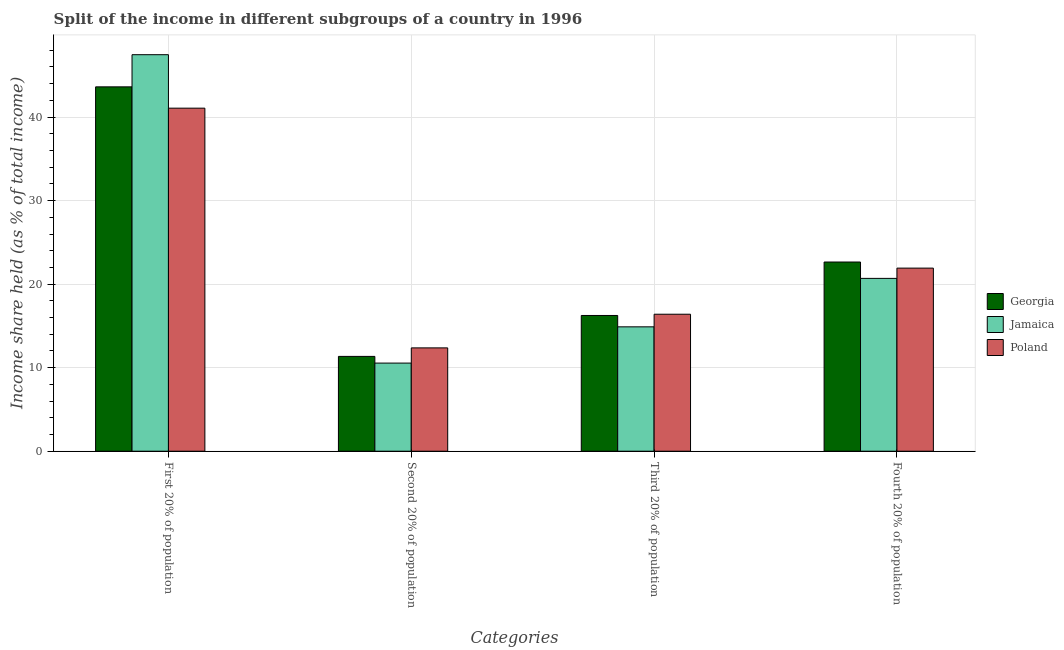How many groups of bars are there?
Offer a very short reply. 4. How many bars are there on the 1st tick from the left?
Provide a short and direct response. 3. How many bars are there on the 2nd tick from the right?
Ensure brevity in your answer.  3. What is the label of the 4th group of bars from the left?
Offer a terse response. Fourth 20% of population. What is the share of the income held by fourth 20% of the population in Georgia?
Give a very brief answer. 22.65. Across all countries, what is the maximum share of the income held by first 20% of the population?
Offer a terse response. 47.47. Across all countries, what is the minimum share of the income held by fourth 20% of the population?
Offer a terse response. 20.69. In which country was the share of the income held by third 20% of the population minimum?
Your response must be concise. Jamaica. What is the total share of the income held by fourth 20% of the population in the graph?
Provide a short and direct response. 65.26. What is the difference between the share of the income held by third 20% of the population in Poland and that in Georgia?
Your answer should be very brief. 0.15. What is the difference between the share of the income held by third 20% of the population in Jamaica and the share of the income held by first 20% of the population in Poland?
Your answer should be very brief. -26.18. What is the average share of the income held by third 20% of the population per country?
Provide a short and direct response. 15.85. What is the difference between the share of the income held by third 20% of the population and share of the income held by second 20% of the population in Georgia?
Keep it short and to the point. 4.9. What is the ratio of the share of the income held by first 20% of the population in Jamaica to that in Poland?
Give a very brief answer. 1.16. Is the difference between the share of the income held by fourth 20% of the population in Jamaica and Georgia greater than the difference between the share of the income held by first 20% of the population in Jamaica and Georgia?
Your answer should be compact. No. What is the difference between the highest and the second highest share of the income held by second 20% of the population?
Keep it short and to the point. 1.02. What is the difference between the highest and the lowest share of the income held by first 20% of the population?
Keep it short and to the point. 6.4. Is it the case that in every country, the sum of the share of the income held by first 20% of the population and share of the income held by third 20% of the population is greater than the sum of share of the income held by second 20% of the population and share of the income held by fourth 20% of the population?
Offer a very short reply. No. What does the 2nd bar from the left in Second 20% of population represents?
Keep it short and to the point. Jamaica. Is it the case that in every country, the sum of the share of the income held by first 20% of the population and share of the income held by second 20% of the population is greater than the share of the income held by third 20% of the population?
Ensure brevity in your answer.  Yes. Are all the bars in the graph horizontal?
Your answer should be very brief. No. Are the values on the major ticks of Y-axis written in scientific E-notation?
Give a very brief answer. No. Does the graph contain grids?
Provide a succinct answer. Yes. Where does the legend appear in the graph?
Provide a succinct answer. Center right. What is the title of the graph?
Provide a short and direct response. Split of the income in different subgroups of a country in 1996. What is the label or title of the X-axis?
Provide a succinct answer. Categories. What is the label or title of the Y-axis?
Keep it short and to the point. Income share held (as % of total income). What is the Income share held (as % of total income) in Georgia in First 20% of population?
Provide a short and direct response. 43.62. What is the Income share held (as % of total income) in Jamaica in First 20% of population?
Your answer should be very brief. 47.47. What is the Income share held (as % of total income) in Poland in First 20% of population?
Give a very brief answer. 41.07. What is the Income share held (as % of total income) in Georgia in Second 20% of population?
Provide a short and direct response. 11.35. What is the Income share held (as % of total income) in Jamaica in Second 20% of population?
Provide a succinct answer. 10.55. What is the Income share held (as % of total income) in Poland in Second 20% of population?
Ensure brevity in your answer.  12.37. What is the Income share held (as % of total income) of Georgia in Third 20% of population?
Provide a succinct answer. 16.25. What is the Income share held (as % of total income) in Jamaica in Third 20% of population?
Ensure brevity in your answer.  14.89. What is the Income share held (as % of total income) of Poland in Third 20% of population?
Your answer should be compact. 16.4. What is the Income share held (as % of total income) of Georgia in Fourth 20% of population?
Give a very brief answer. 22.65. What is the Income share held (as % of total income) of Jamaica in Fourth 20% of population?
Offer a terse response. 20.69. What is the Income share held (as % of total income) in Poland in Fourth 20% of population?
Offer a very short reply. 21.92. Across all Categories, what is the maximum Income share held (as % of total income) in Georgia?
Your answer should be very brief. 43.62. Across all Categories, what is the maximum Income share held (as % of total income) in Jamaica?
Keep it short and to the point. 47.47. Across all Categories, what is the maximum Income share held (as % of total income) in Poland?
Provide a short and direct response. 41.07. Across all Categories, what is the minimum Income share held (as % of total income) in Georgia?
Your response must be concise. 11.35. Across all Categories, what is the minimum Income share held (as % of total income) in Jamaica?
Give a very brief answer. 10.55. Across all Categories, what is the minimum Income share held (as % of total income) of Poland?
Keep it short and to the point. 12.37. What is the total Income share held (as % of total income) of Georgia in the graph?
Provide a short and direct response. 93.87. What is the total Income share held (as % of total income) in Jamaica in the graph?
Your response must be concise. 93.6. What is the total Income share held (as % of total income) of Poland in the graph?
Offer a terse response. 91.76. What is the difference between the Income share held (as % of total income) of Georgia in First 20% of population and that in Second 20% of population?
Give a very brief answer. 32.27. What is the difference between the Income share held (as % of total income) in Jamaica in First 20% of population and that in Second 20% of population?
Your answer should be compact. 36.92. What is the difference between the Income share held (as % of total income) in Poland in First 20% of population and that in Second 20% of population?
Offer a terse response. 28.7. What is the difference between the Income share held (as % of total income) in Georgia in First 20% of population and that in Third 20% of population?
Offer a very short reply. 27.37. What is the difference between the Income share held (as % of total income) in Jamaica in First 20% of population and that in Third 20% of population?
Make the answer very short. 32.58. What is the difference between the Income share held (as % of total income) in Poland in First 20% of population and that in Third 20% of population?
Keep it short and to the point. 24.67. What is the difference between the Income share held (as % of total income) in Georgia in First 20% of population and that in Fourth 20% of population?
Offer a very short reply. 20.97. What is the difference between the Income share held (as % of total income) in Jamaica in First 20% of population and that in Fourth 20% of population?
Ensure brevity in your answer.  26.78. What is the difference between the Income share held (as % of total income) of Poland in First 20% of population and that in Fourth 20% of population?
Provide a succinct answer. 19.15. What is the difference between the Income share held (as % of total income) in Georgia in Second 20% of population and that in Third 20% of population?
Offer a terse response. -4.9. What is the difference between the Income share held (as % of total income) in Jamaica in Second 20% of population and that in Third 20% of population?
Your response must be concise. -4.34. What is the difference between the Income share held (as % of total income) of Poland in Second 20% of population and that in Third 20% of population?
Offer a very short reply. -4.03. What is the difference between the Income share held (as % of total income) of Jamaica in Second 20% of population and that in Fourth 20% of population?
Provide a succinct answer. -10.14. What is the difference between the Income share held (as % of total income) in Poland in Second 20% of population and that in Fourth 20% of population?
Your answer should be very brief. -9.55. What is the difference between the Income share held (as % of total income) of Georgia in Third 20% of population and that in Fourth 20% of population?
Provide a succinct answer. -6.4. What is the difference between the Income share held (as % of total income) in Poland in Third 20% of population and that in Fourth 20% of population?
Your response must be concise. -5.52. What is the difference between the Income share held (as % of total income) in Georgia in First 20% of population and the Income share held (as % of total income) in Jamaica in Second 20% of population?
Provide a succinct answer. 33.07. What is the difference between the Income share held (as % of total income) of Georgia in First 20% of population and the Income share held (as % of total income) of Poland in Second 20% of population?
Ensure brevity in your answer.  31.25. What is the difference between the Income share held (as % of total income) of Jamaica in First 20% of population and the Income share held (as % of total income) of Poland in Second 20% of population?
Your answer should be compact. 35.1. What is the difference between the Income share held (as % of total income) in Georgia in First 20% of population and the Income share held (as % of total income) in Jamaica in Third 20% of population?
Provide a short and direct response. 28.73. What is the difference between the Income share held (as % of total income) in Georgia in First 20% of population and the Income share held (as % of total income) in Poland in Third 20% of population?
Your answer should be very brief. 27.22. What is the difference between the Income share held (as % of total income) in Jamaica in First 20% of population and the Income share held (as % of total income) in Poland in Third 20% of population?
Your answer should be compact. 31.07. What is the difference between the Income share held (as % of total income) in Georgia in First 20% of population and the Income share held (as % of total income) in Jamaica in Fourth 20% of population?
Your answer should be very brief. 22.93. What is the difference between the Income share held (as % of total income) in Georgia in First 20% of population and the Income share held (as % of total income) in Poland in Fourth 20% of population?
Provide a short and direct response. 21.7. What is the difference between the Income share held (as % of total income) of Jamaica in First 20% of population and the Income share held (as % of total income) of Poland in Fourth 20% of population?
Provide a short and direct response. 25.55. What is the difference between the Income share held (as % of total income) in Georgia in Second 20% of population and the Income share held (as % of total income) in Jamaica in Third 20% of population?
Your response must be concise. -3.54. What is the difference between the Income share held (as % of total income) in Georgia in Second 20% of population and the Income share held (as % of total income) in Poland in Third 20% of population?
Ensure brevity in your answer.  -5.05. What is the difference between the Income share held (as % of total income) in Jamaica in Second 20% of population and the Income share held (as % of total income) in Poland in Third 20% of population?
Offer a very short reply. -5.85. What is the difference between the Income share held (as % of total income) of Georgia in Second 20% of population and the Income share held (as % of total income) of Jamaica in Fourth 20% of population?
Make the answer very short. -9.34. What is the difference between the Income share held (as % of total income) of Georgia in Second 20% of population and the Income share held (as % of total income) of Poland in Fourth 20% of population?
Provide a succinct answer. -10.57. What is the difference between the Income share held (as % of total income) of Jamaica in Second 20% of population and the Income share held (as % of total income) of Poland in Fourth 20% of population?
Provide a succinct answer. -11.37. What is the difference between the Income share held (as % of total income) of Georgia in Third 20% of population and the Income share held (as % of total income) of Jamaica in Fourth 20% of population?
Ensure brevity in your answer.  -4.44. What is the difference between the Income share held (as % of total income) of Georgia in Third 20% of population and the Income share held (as % of total income) of Poland in Fourth 20% of population?
Your answer should be compact. -5.67. What is the difference between the Income share held (as % of total income) of Jamaica in Third 20% of population and the Income share held (as % of total income) of Poland in Fourth 20% of population?
Give a very brief answer. -7.03. What is the average Income share held (as % of total income) in Georgia per Categories?
Give a very brief answer. 23.47. What is the average Income share held (as % of total income) in Jamaica per Categories?
Keep it short and to the point. 23.4. What is the average Income share held (as % of total income) of Poland per Categories?
Provide a succinct answer. 22.94. What is the difference between the Income share held (as % of total income) in Georgia and Income share held (as % of total income) in Jamaica in First 20% of population?
Your answer should be very brief. -3.85. What is the difference between the Income share held (as % of total income) of Georgia and Income share held (as % of total income) of Poland in First 20% of population?
Make the answer very short. 2.55. What is the difference between the Income share held (as % of total income) in Jamaica and Income share held (as % of total income) in Poland in First 20% of population?
Provide a succinct answer. 6.4. What is the difference between the Income share held (as % of total income) of Georgia and Income share held (as % of total income) of Poland in Second 20% of population?
Your answer should be very brief. -1.02. What is the difference between the Income share held (as % of total income) in Jamaica and Income share held (as % of total income) in Poland in Second 20% of population?
Offer a very short reply. -1.82. What is the difference between the Income share held (as % of total income) in Georgia and Income share held (as % of total income) in Jamaica in Third 20% of population?
Your answer should be compact. 1.36. What is the difference between the Income share held (as % of total income) of Jamaica and Income share held (as % of total income) of Poland in Third 20% of population?
Your answer should be compact. -1.51. What is the difference between the Income share held (as % of total income) of Georgia and Income share held (as % of total income) of Jamaica in Fourth 20% of population?
Your answer should be very brief. 1.96. What is the difference between the Income share held (as % of total income) in Georgia and Income share held (as % of total income) in Poland in Fourth 20% of population?
Your answer should be compact. 0.73. What is the difference between the Income share held (as % of total income) in Jamaica and Income share held (as % of total income) in Poland in Fourth 20% of population?
Give a very brief answer. -1.23. What is the ratio of the Income share held (as % of total income) in Georgia in First 20% of population to that in Second 20% of population?
Provide a short and direct response. 3.84. What is the ratio of the Income share held (as % of total income) in Jamaica in First 20% of population to that in Second 20% of population?
Your answer should be very brief. 4.5. What is the ratio of the Income share held (as % of total income) in Poland in First 20% of population to that in Second 20% of population?
Offer a terse response. 3.32. What is the ratio of the Income share held (as % of total income) in Georgia in First 20% of population to that in Third 20% of population?
Provide a succinct answer. 2.68. What is the ratio of the Income share held (as % of total income) of Jamaica in First 20% of population to that in Third 20% of population?
Offer a terse response. 3.19. What is the ratio of the Income share held (as % of total income) of Poland in First 20% of population to that in Third 20% of population?
Offer a terse response. 2.5. What is the ratio of the Income share held (as % of total income) of Georgia in First 20% of population to that in Fourth 20% of population?
Your answer should be very brief. 1.93. What is the ratio of the Income share held (as % of total income) in Jamaica in First 20% of population to that in Fourth 20% of population?
Offer a terse response. 2.29. What is the ratio of the Income share held (as % of total income) of Poland in First 20% of population to that in Fourth 20% of population?
Keep it short and to the point. 1.87. What is the ratio of the Income share held (as % of total income) of Georgia in Second 20% of population to that in Third 20% of population?
Give a very brief answer. 0.7. What is the ratio of the Income share held (as % of total income) of Jamaica in Second 20% of population to that in Third 20% of population?
Your response must be concise. 0.71. What is the ratio of the Income share held (as % of total income) of Poland in Second 20% of population to that in Third 20% of population?
Give a very brief answer. 0.75. What is the ratio of the Income share held (as % of total income) of Georgia in Second 20% of population to that in Fourth 20% of population?
Your response must be concise. 0.5. What is the ratio of the Income share held (as % of total income) in Jamaica in Second 20% of population to that in Fourth 20% of population?
Ensure brevity in your answer.  0.51. What is the ratio of the Income share held (as % of total income) in Poland in Second 20% of population to that in Fourth 20% of population?
Provide a succinct answer. 0.56. What is the ratio of the Income share held (as % of total income) in Georgia in Third 20% of population to that in Fourth 20% of population?
Your answer should be compact. 0.72. What is the ratio of the Income share held (as % of total income) of Jamaica in Third 20% of population to that in Fourth 20% of population?
Give a very brief answer. 0.72. What is the ratio of the Income share held (as % of total income) in Poland in Third 20% of population to that in Fourth 20% of population?
Your answer should be very brief. 0.75. What is the difference between the highest and the second highest Income share held (as % of total income) in Georgia?
Keep it short and to the point. 20.97. What is the difference between the highest and the second highest Income share held (as % of total income) in Jamaica?
Offer a terse response. 26.78. What is the difference between the highest and the second highest Income share held (as % of total income) of Poland?
Offer a terse response. 19.15. What is the difference between the highest and the lowest Income share held (as % of total income) of Georgia?
Keep it short and to the point. 32.27. What is the difference between the highest and the lowest Income share held (as % of total income) of Jamaica?
Your response must be concise. 36.92. What is the difference between the highest and the lowest Income share held (as % of total income) in Poland?
Offer a very short reply. 28.7. 